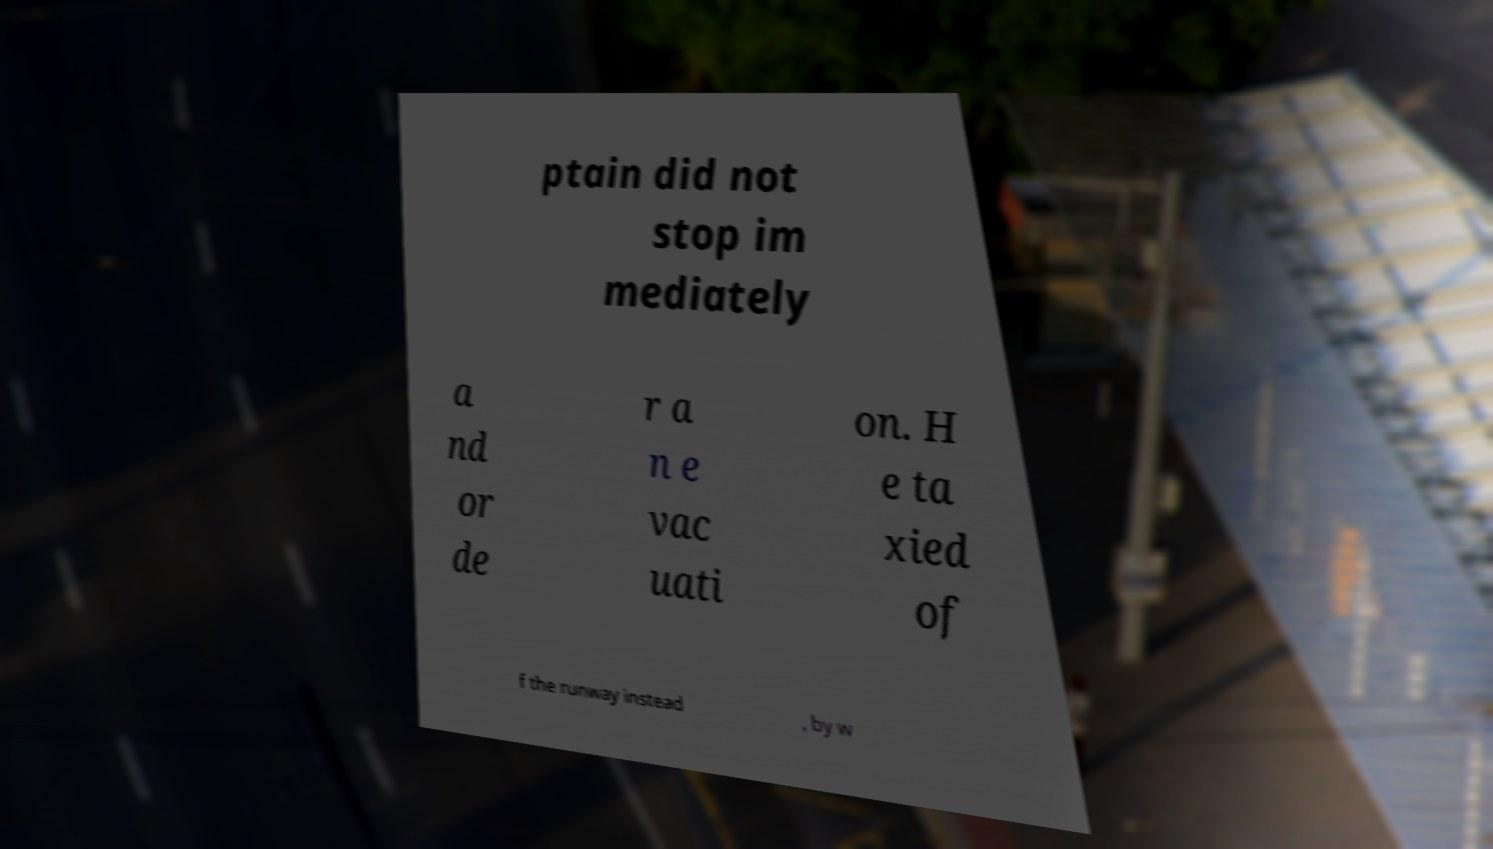Could you extract and type out the text from this image? ptain did not stop im mediately a nd or de r a n e vac uati on. H e ta xied of f the runway instead , by w 